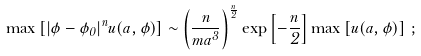Convert formula to latex. <formula><loc_0><loc_0><loc_500><loc_500>\max \left [ | \phi - \phi _ { 0 } | ^ { n } u ( a , \phi ) \right ] \sim \left ( \frac { n } { m a ^ { 3 } } \right ) ^ { \frac { n } { 2 } } \exp \left [ - \frac { n } { 2 } \right ] \max \left [ u ( a , \phi ) \right ] \, ;</formula> 